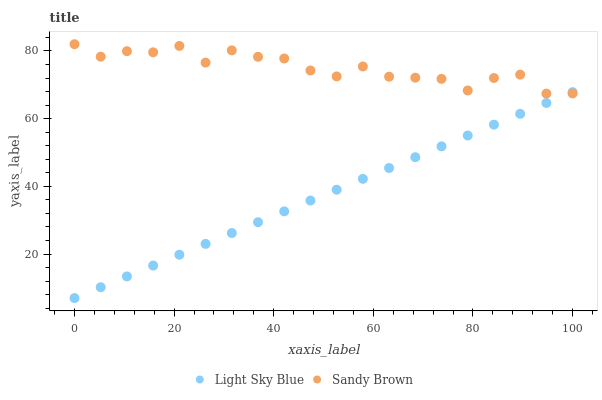Does Light Sky Blue have the minimum area under the curve?
Answer yes or no. Yes. Does Sandy Brown have the maximum area under the curve?
Answer yes or no. Yes. Does Sandy Brown have the minimum area under the curve?
Answer yes or no. No. Is Light Sky Blue the smoothest?
Answer yes or no. Yes. Is Sandy Brown the roughest?
Answer yes or no. Yes. Is Sandy Brown the smoothest?
Answer yes or no. No. Does Light Sky Blue have the lowest value?
Answer yes or no. Yes. Does Sandy Brown have the lowest value?
Answer yes or no. No. Does Sandy Brown have the highest value?
Answer yes or no. Yes. Does Sandy Brown intersect Light Sky Blue?
Answer yes or no. Yes. Is Sandy Brown less than Light Sky Blue?
Answer yes or no. No. Is Sandy Brown greater than Light Sky Blue?
Answer yes or no. No. 